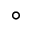<formula> <loc_0><loc_0><loc_500><loc_500>\circ</formula> 